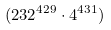<formula> <loc_0><loc_0><loc_500><loc_500>( 2 3 2 ^ { 4 2 9 } \cdot 4 ^ { 4 3 1 } )</formula> 